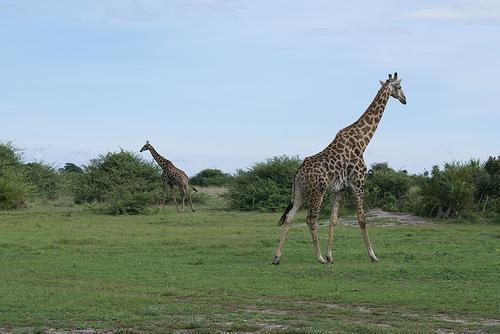How many giraffes are in the picture?
Give a very brief answer. 2. How many ears does a giraffe have?
Give a very brief answer. 2. 